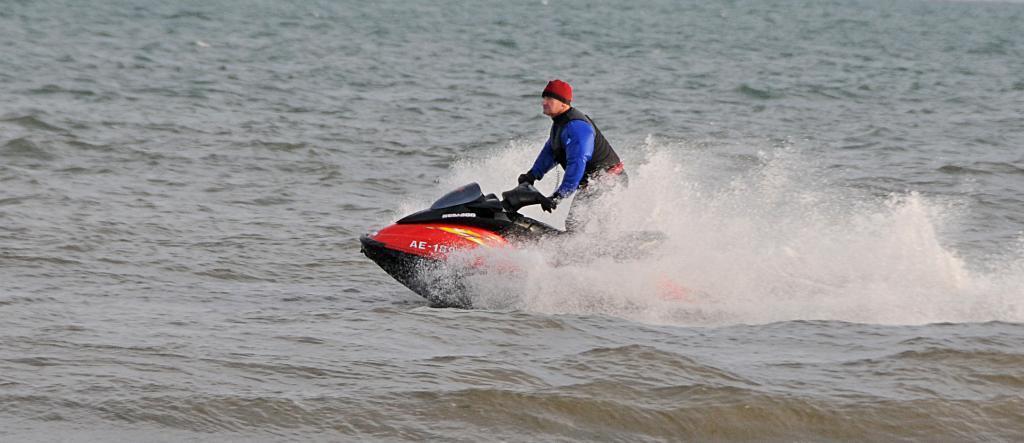How would you summarize this image in a sentence or two? In this image there is a person surfing on water. 